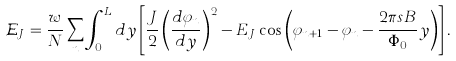Convert formula to latex. <formula><loc_0><loc_0><loc_500><loc_500>\mathcal { E } _ { J } = \frac { w } { N } \sum _ { n } \int _ { 0 } ^ { L } d y \left [ \frac { J } { 2 } \left ( \frac { d \varphi _ { n } } { d y } \right ) ^ { 2 } - E _ { J } \cos \left ( \varphi _ { n + 1 } - \varphi _ { n } - \frac { 2 \pi s B } { \Phi _ { 0 } } y \right ) \right ] .</formula> 